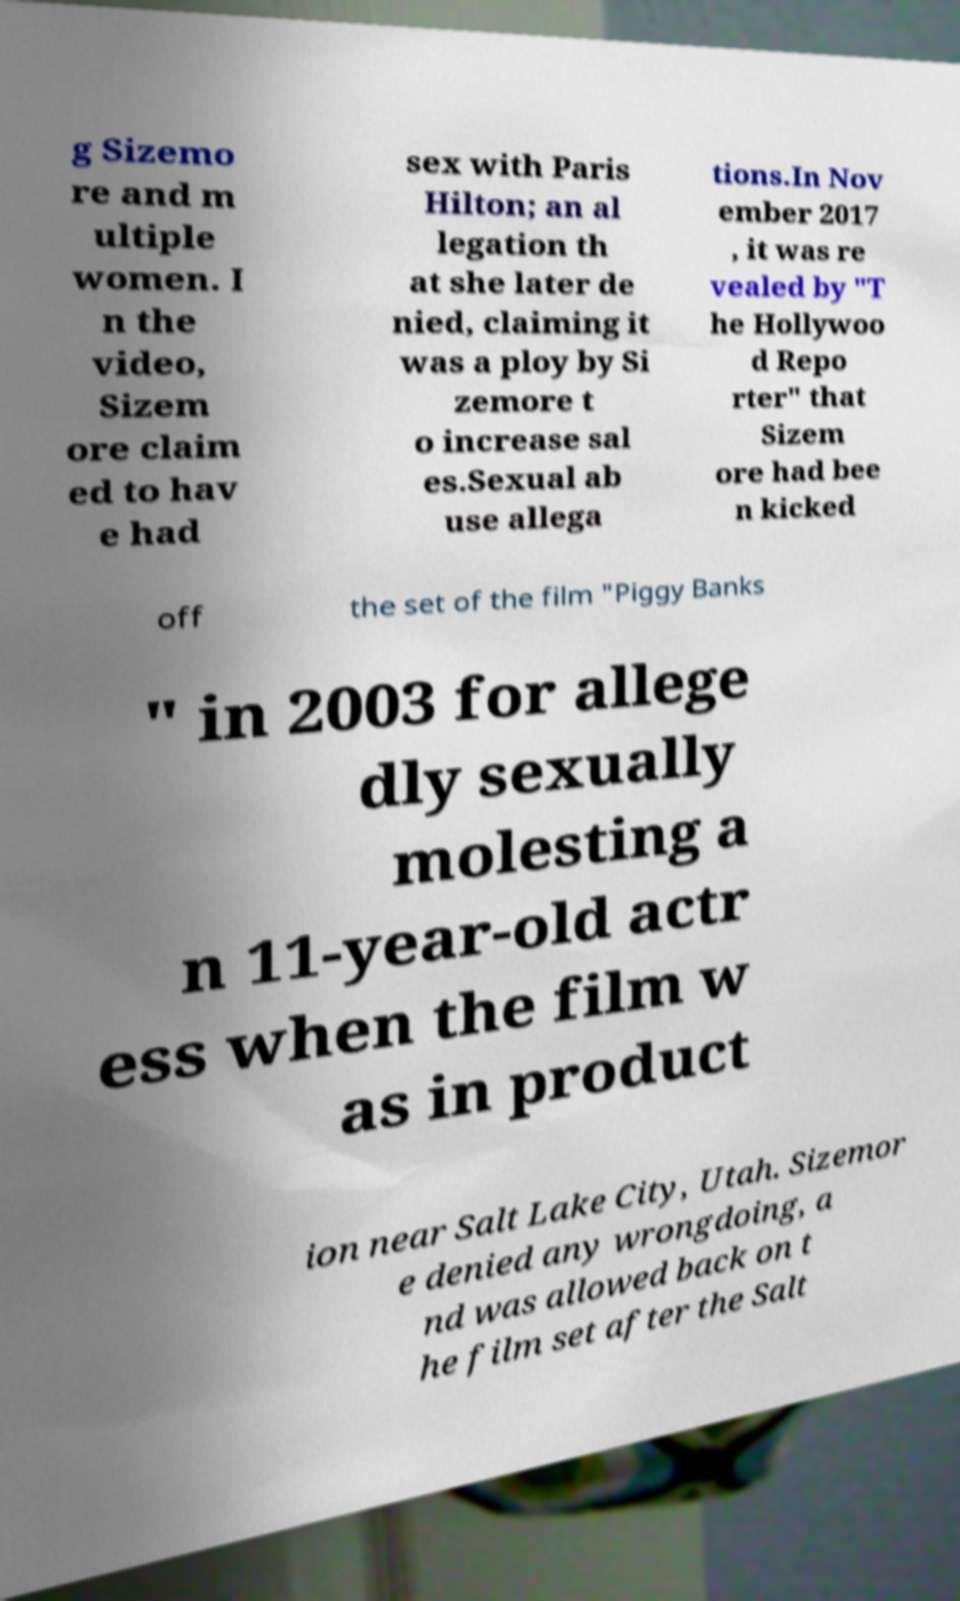Could you assist in decoding the text presented in this image and type it out clearly? g Sizemo re and m ultiple women. I n the video, Sizem ore claim ed to hav e had sex with Paris Hilton; an al legation th at she later de nied, claiming it was a ploy by Si zemore t o increase sal es.Sexual ab use allega tions.In Nov ember 2017 , it was re vealed by "T he Hollywoo d Repo rter" that Sizem ore had bee n kicked off the set of the film "Piggy Banks " in 2003 for allege dly sexually molesting a n 11-year-old actr ess when the film w as in product ion near Salt Lake City, Utah. Sizemor e denied any wrongdoing, a nd was allowed back on t he film set after the Salt 